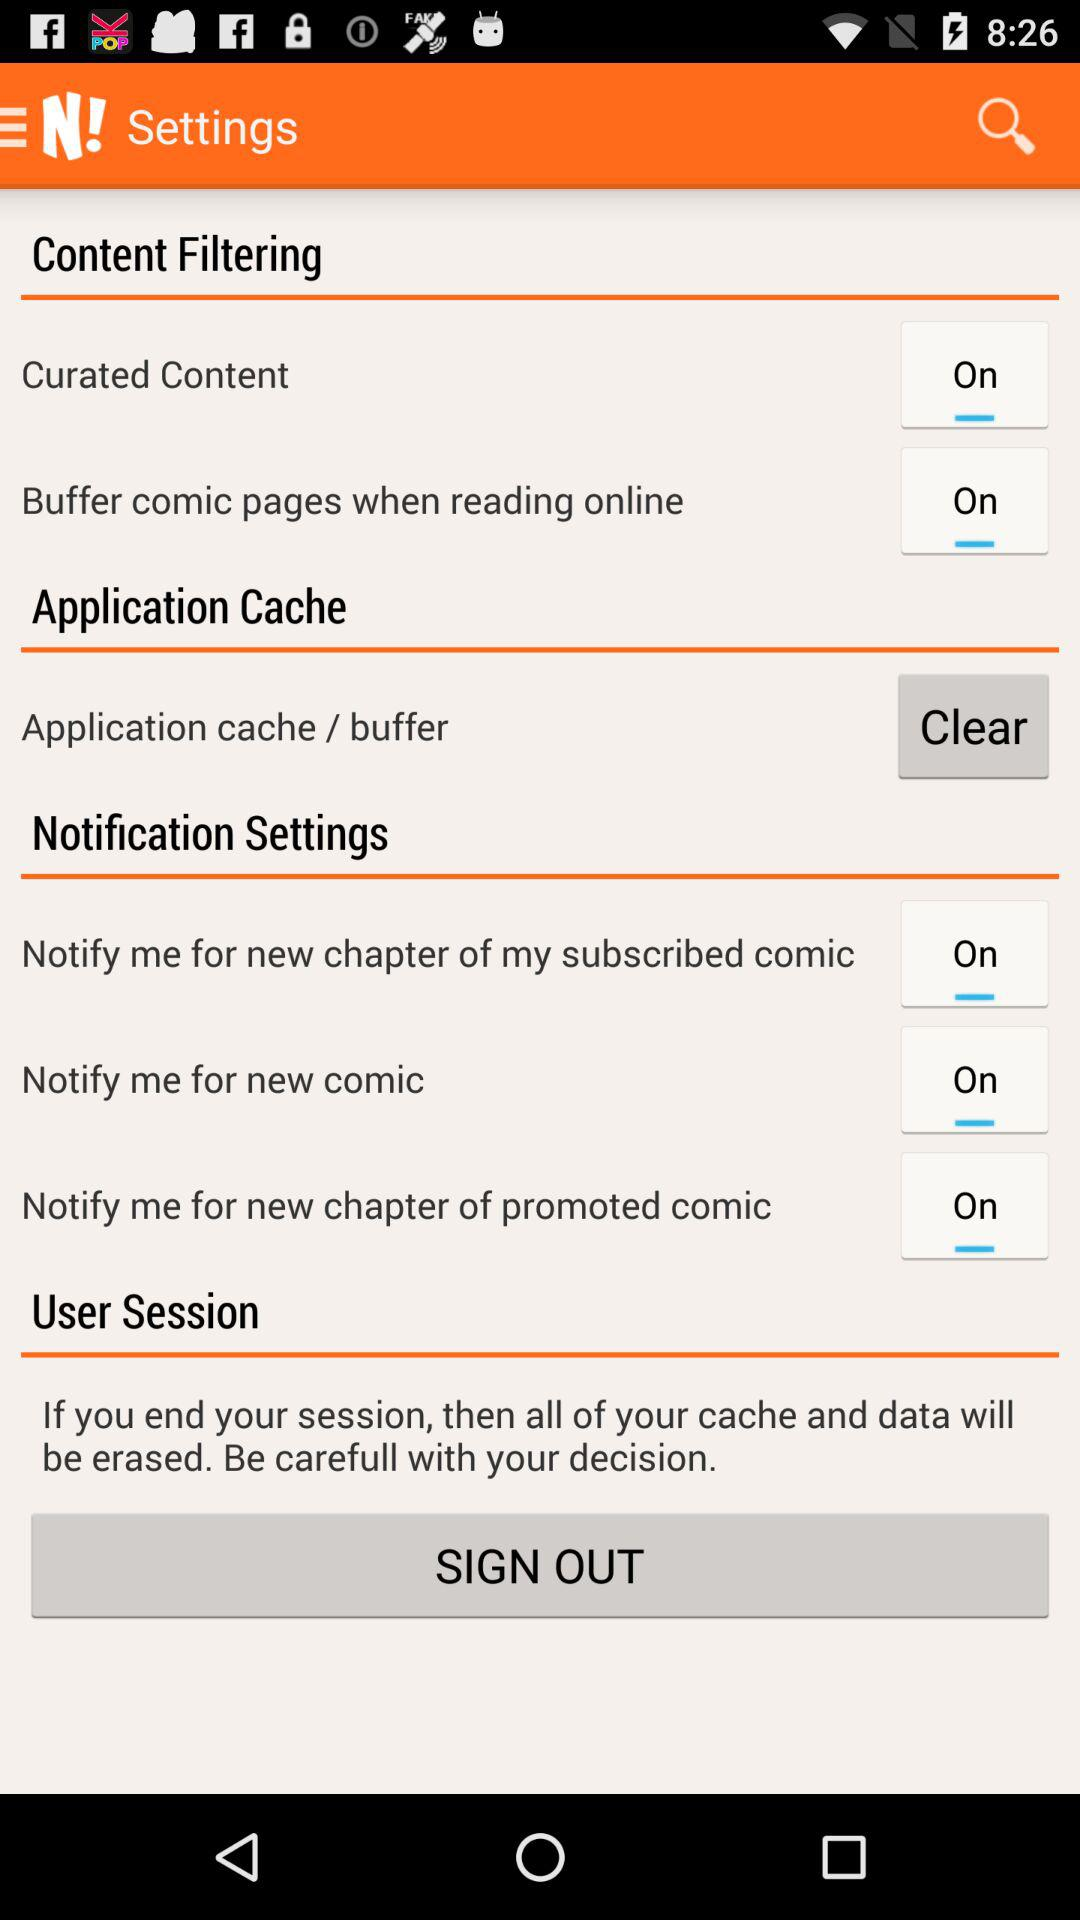How big is the storage allocation for our cache and data?
When the provided information is insufficient, respond with <no answer>. <no answer> 